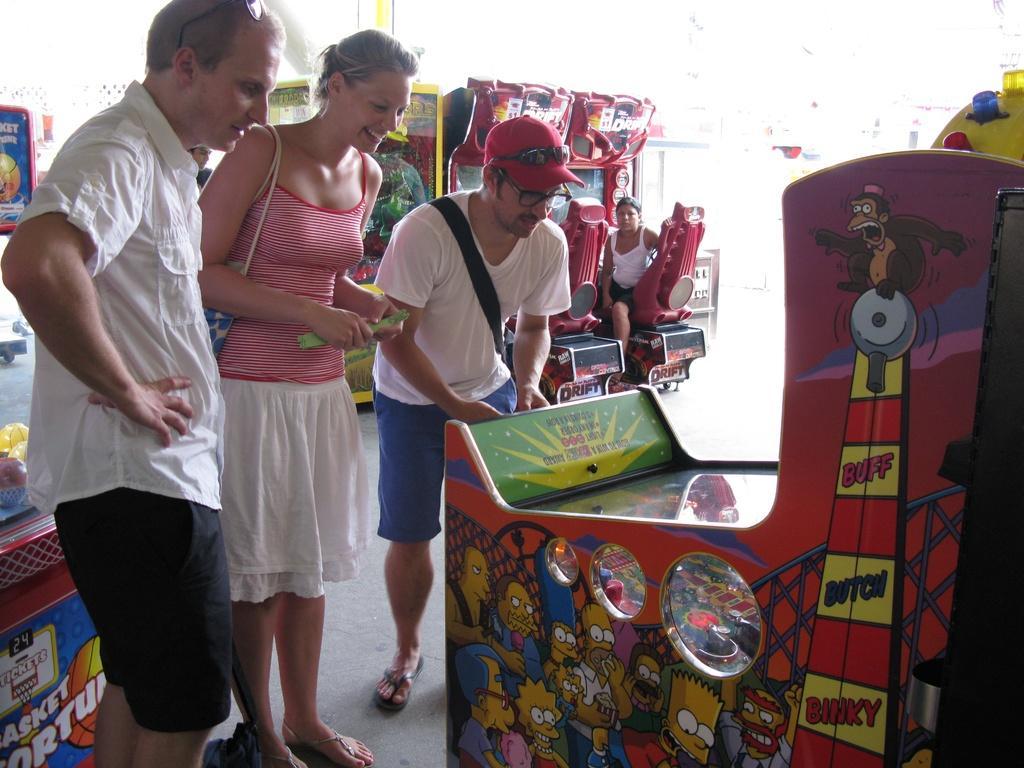How would you summarize this image in a sentence or two? In this image I can see people where one is sitting and rest all are standing. I can see three of them are wearing white colour dress. I can also see number of video games and on these things I can see something is written. 